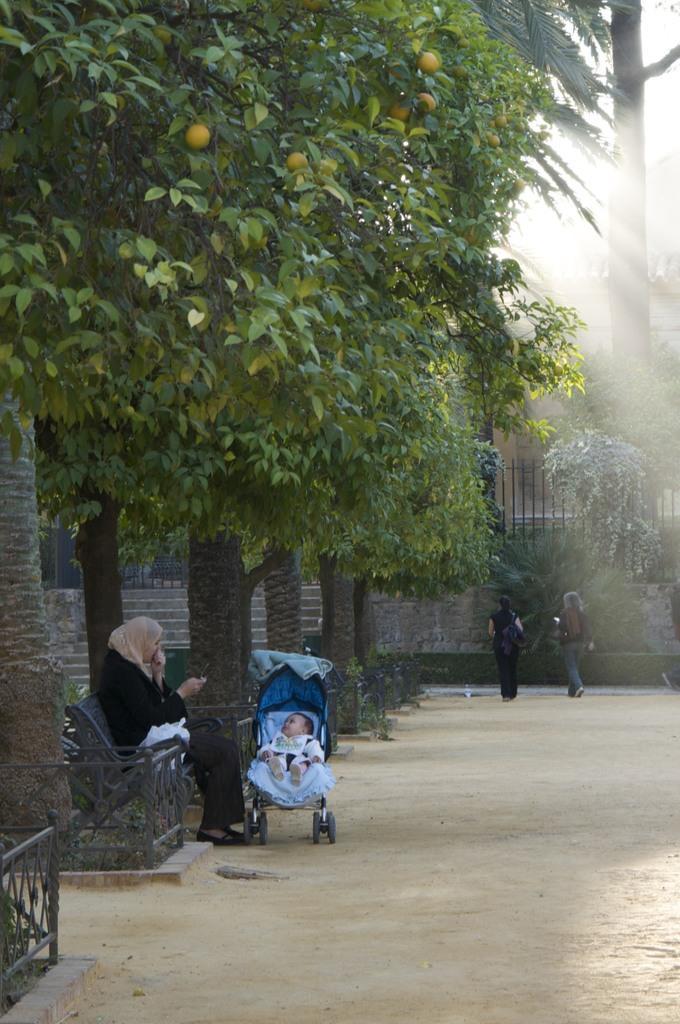Describe this image in one or two sentences. In this image on the left, there is a woman, she is sitting on the bench, in front of her there is a baby and there are trees. In the middle there are two women, they are walking. In the background there are trees. 